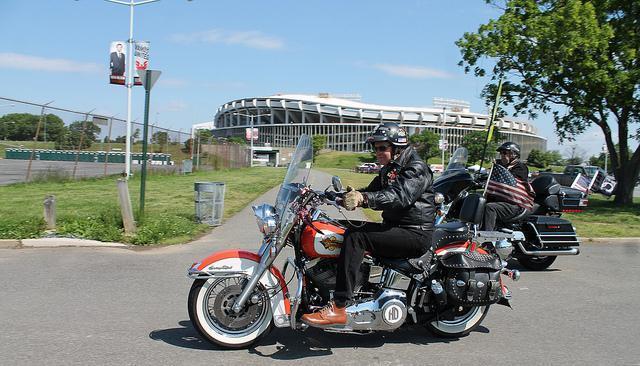How many people can you see?
Give a very brief answer. 2. How many motorcycles are in the picture?
Give a very brief answer. 2. 